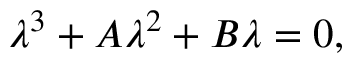<formula> <loc_0><loc_0><loc_500><loc_500>\lambda ^ { 3 } + A \lambda ^ { 2 } + B \lambda = 0 ,</formula> 